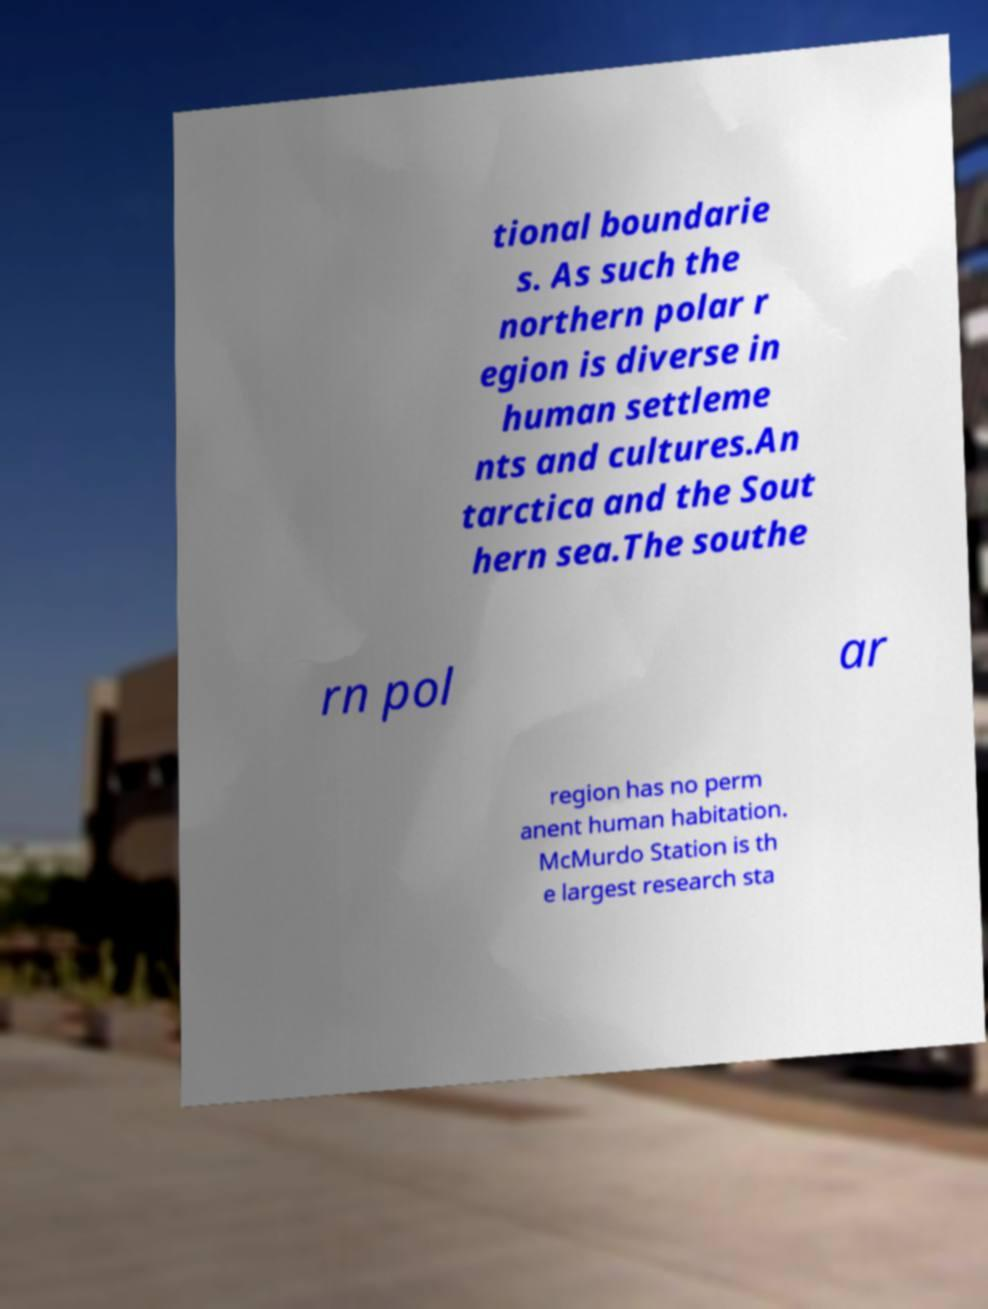Can you read and provide the text displayed in the image?This photo seems to have some interesting text. Can you extract and type it out for me? tional boundarie s. As such the northern polar r egion is diverse in human settleme nts and cultures.An tarctica and the Sout hern sea.The southe rn pol ar region has no perm anent human habitation. McMurdo Station is th e largest research sta 